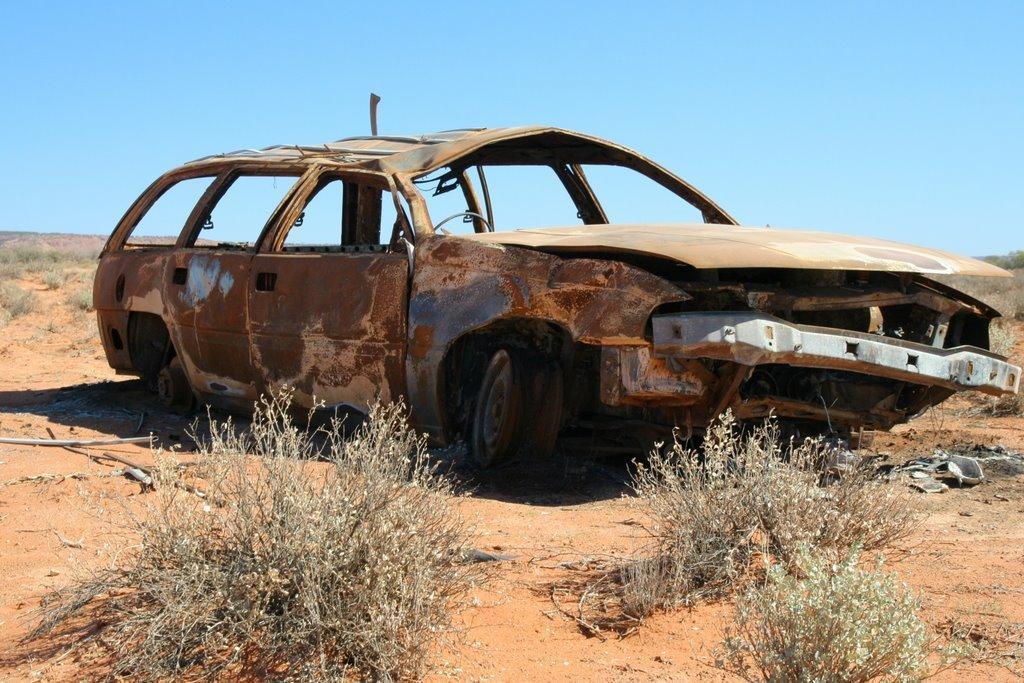How would you summarize this image in a sentence or two? In the image there is a scrapped car on a land and around that land there are some dry pants. 